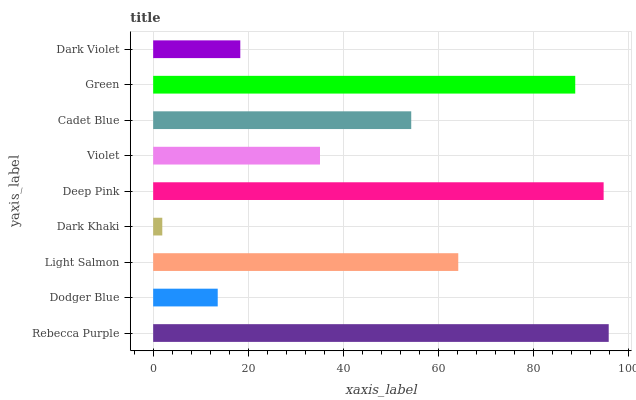Is Dark Khaki the minimum?
Answer yes or no. Yes. Is Rebecca Purple the maximum?
Answer yes or no. Yes. Is Dodger Blue the minimum?
Answer yes or no. No. Is Dodger Blue the maximum?
Answer yes or no. No. Is Rebecca Purple greater than Dodger Blue?
Answer yes or no. Yes. Is Dodger Blue less than Rebecca Purple?
Answer yes or no. Yes. Is Dodger Blue greater than Rebecca Purple?
Answer yes or no. No. Is Rebecca Purple less than Dodger Blue?
Answer yes or no. No. Is Cadet Blue the high median?
Answer yes or no. Yes. Is Cadet Blue the low median?
Answer yes or no. Yes. Is Dark Khaki the high median?
Answer yes or no. No. Is Dodger Blue the low median?
Answer yes or no. No. 